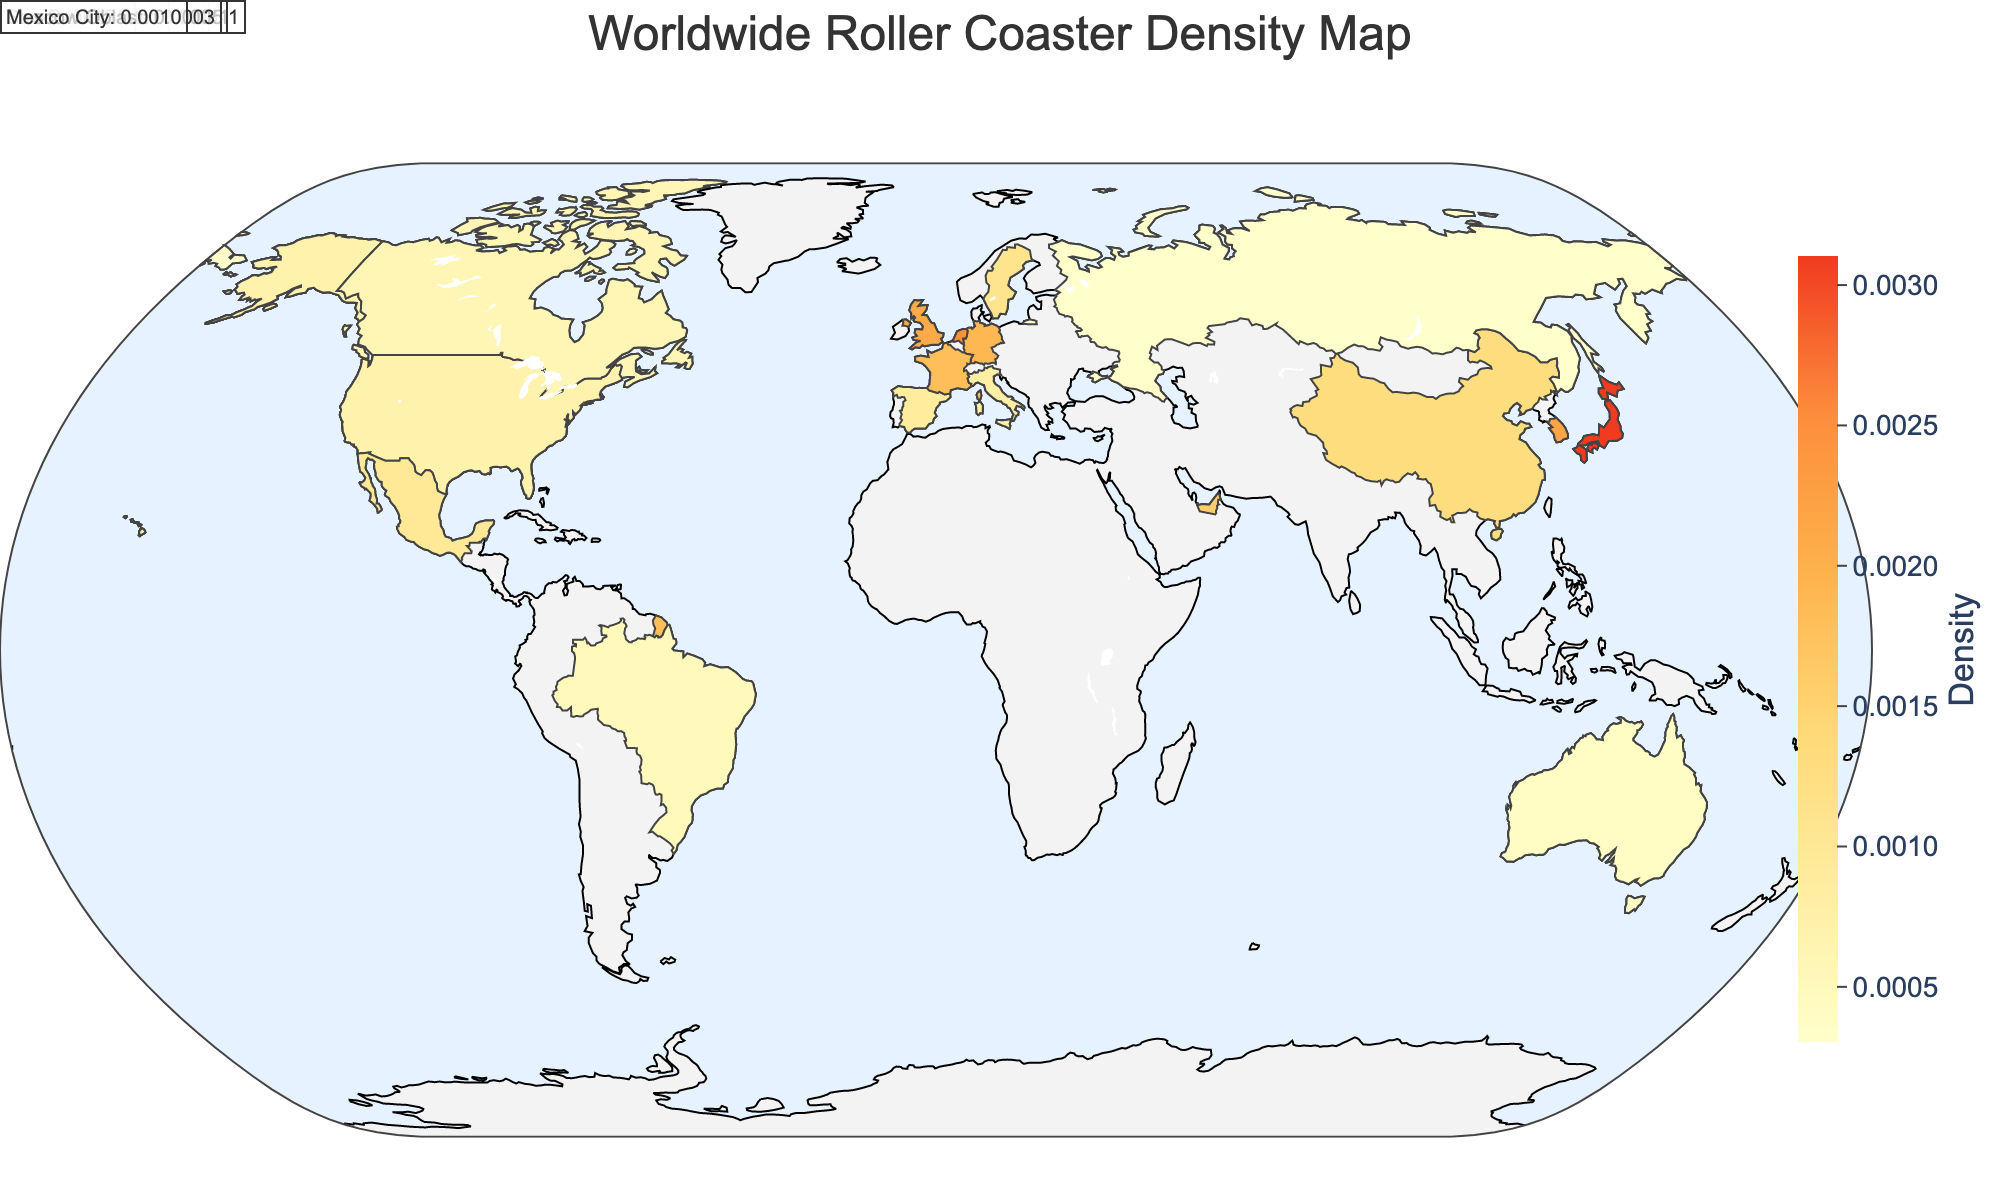What is the title of the plot? The title can be found at the top of the plot. It provides a brief description of what the plot is showing. The title is "Worldwide Roller Coaster Density Map"
Answer: Worldwide Roller Coaster Density Map Which region has the highest density of roller coasters per square kilometer? To determine this, look for the region with the highest value on the color scale and hover over that region for details. Honshu in Japan has the highest density with a value of 0.0031.
Answer: Honshu, Japan How does the roller coaster density in the USA's Midwest compare to that in South Korea's Gyeonggi region? Compare the values given for these two regions. The Midwest has a density of 0.0015 and Gyeonggi has a density of 0.0022.
Answer: Gyeonggi region is higher What is the difference in roller coaster density between Catalonia, Spain, and Ile-de-France, France? Subtract the density of Catalonia (0.0009) from Ile-de-France (0.0018). The difference is 0.0018 - 0.0009 = 0.0009.
Answer: 0.0009 Identify the region with the lowest density of roller coasters per square kilometer. Locate the region with the lowest value on the color scale. Moscow Oblast in Russia has the lowest density with a value of 0.0003.
Answer: Moscow Oblast, Russia What is the average roller coaster density of the USA regions listed (Northeast, Midwest, South, West)? Sum the values for Northeast (0.0023), Midwest (0.0015), South (0.0011), and West (0.0007) and divide by 4. The average is (0.0023 + 0.0015 + 0.0011 + 0.0007) / 4 = 0.0014.
Answer: 0.0014 If another region in Canada had a roller coaster density of 0.0012, how would it compare to Ontario? Ontario has a density of 0.0006. 0.0012 is greater than 0.0006.
Answer: Higher How many regions have a roller coaster density greater than 0.0020? Count the regions with a density value above 0.0020. Northeast USA, Honshu Japan, England UK, South Holland Netherlands, and Gyeonggi South Korea qualify.
Answer: 5 Which region has nearly half the roller coaster density of Honshu, Japan? Honshu has a density of 0.0031. Half of that is approximately 0.00155. The Midwest USA (0.0015) is the closest to being half of Honshu's density.
Answer: Midwest, USA 